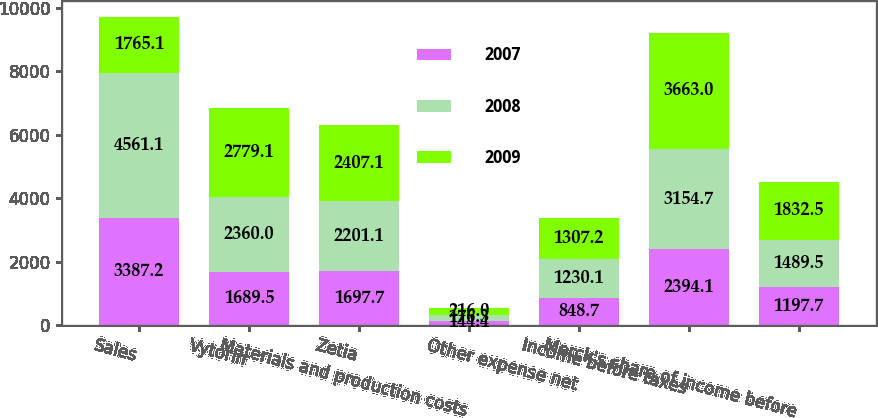Convert chart to OTSL. <chart><loc_0><loc_0><loc_500><loc_500><stacked_bar_chart><ecel><fcel>Sales<fcel>Vytorin<fcel>Zetia<fcel>Materials and production costs<fcel>Other expense net<fcel>Income before taxes<fcel>Merck's share of income before<nl><fcel>2007<fcel>3387.2<fcel>1689.5<fcel>1697.7<fcel>144.4<fcel>848.7<fcel>2394.1<fcel>1197.7<nl><fcel>2008<fcel>4561.1<fcel>2360<fcel>2201.1<fcel>176.3<fcel>1230.1<fcel>3154.7<fcel>1489.5<nl><fcel>2009<fcel>1765.1<fcel>2779.1<fcel>2407.1<fcel>216<fcel>1307.2<fcel>3663<fcel>1832.5<nl></chart> 